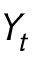Convert formula to latex. <formula><loc_0><loc_0><loc_500><loc_500>Y _ { t }</formula> 